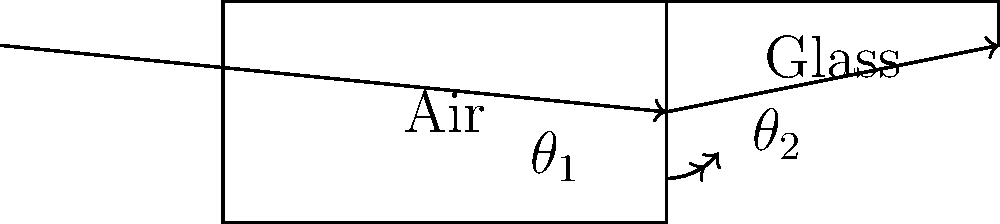In your virtual conversation session about physics, you're discussing the refraction of light. Using the ray diagram provided, explain how you would determine the refractive index of glass relative to air if you know that $\theta_1 = 30°$ and $\theta_2 = 20°$. What law would you apply, and what is the refractive index of glass? To determine the refractive index of glass relative to air, we can follow these steps:

1. Identify the applicable law: We use Snell's law, which states that the ratio of the sines of the angles of incidence and refraction is equivalent to the ratio of phase velocities in the two media, or equivalent to the reciprocal of the ratio of the indices of refraction.

2. Write Snell's law mathematically:
   $$\frac{\sin \theta_1}{\sin \theta_2} = \frac{n_2}{n_1}$$
   where $n_1$ is the refractive index of air and $n_2$ is the refractive index of glass.

3. We know that the refractive index of air is approximately 1, so $n_1 = 1$.

4. Substitute the known values into Snell's law:
   $$\frac{\sin 30°}{\sin 20°} = \frac{n_{\text{glass}}}{1}$$

5. Calculate the sine values:
   $$\frac{0.5}{0.342} = n_{\text{glass}}$$

6. Solve for $n_{\text{glass}}$:
   $$n_{\text{glass}} = \frac{0.5}{0.342} \approx 1.46$$

Therefore, the refractive index of glass relative to air is approximately 1.46.
Answer: $n_{\text{glass}} \approx 1.46$ 